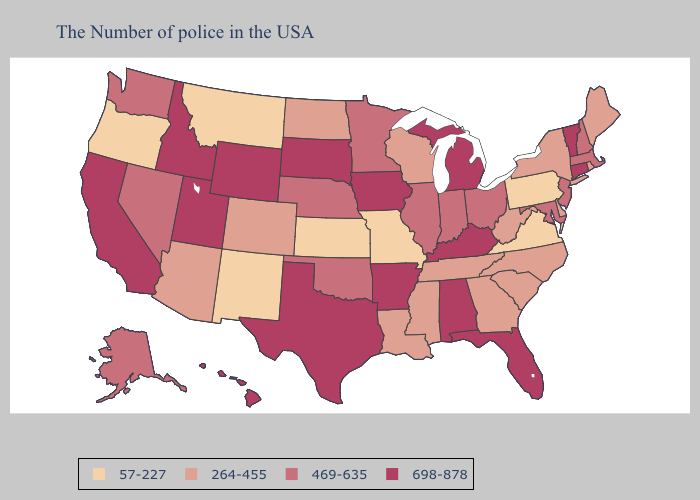Is the legend a continuous bar?
Quick response, please. No. Name the states that have a value in the range 698-878?
Concise answer only. Vermont, Connecticut, Florida, Michigan, Kentucky, Alabama, Arkansas, Iowa, Texas, South Dakota, Wyoming, Utah, Idaho, California, Hawaii. Among the states that border Missouri , does Kansas have the lowest value?
Answer briefly. Yes. What is the lowest value in the South?
Short answer required. 57-227. Among the states that border South Dakota , which have the lowest value?
Short answer required. Montana. What is the value of New York?
Answer briefly. 264-455. Does the first symbol in the legend represent the smallest category?
Be succinct. Yes. Does Pennsylvania have the lowest value in the Northeast?
Quick response, please. Yes. Among the states that border Michigan , which have the highest value?
Short answer required. Ohio, Indiana. Does Illinois have the same value as South Dakota?
Be succinct. No. Does Wyoming have a higher value than Oklahoma?
Short answer required. Yes. Does Kentucky have a higher value than North Carolina?
Be succinct. Yes. What is the value of Michigan?
Write a very short answer. 698-878. What is the value of Maine?
Write a very short answer. 264-455. Is the legend a continuous bar?
Give a very brief answer. No. 